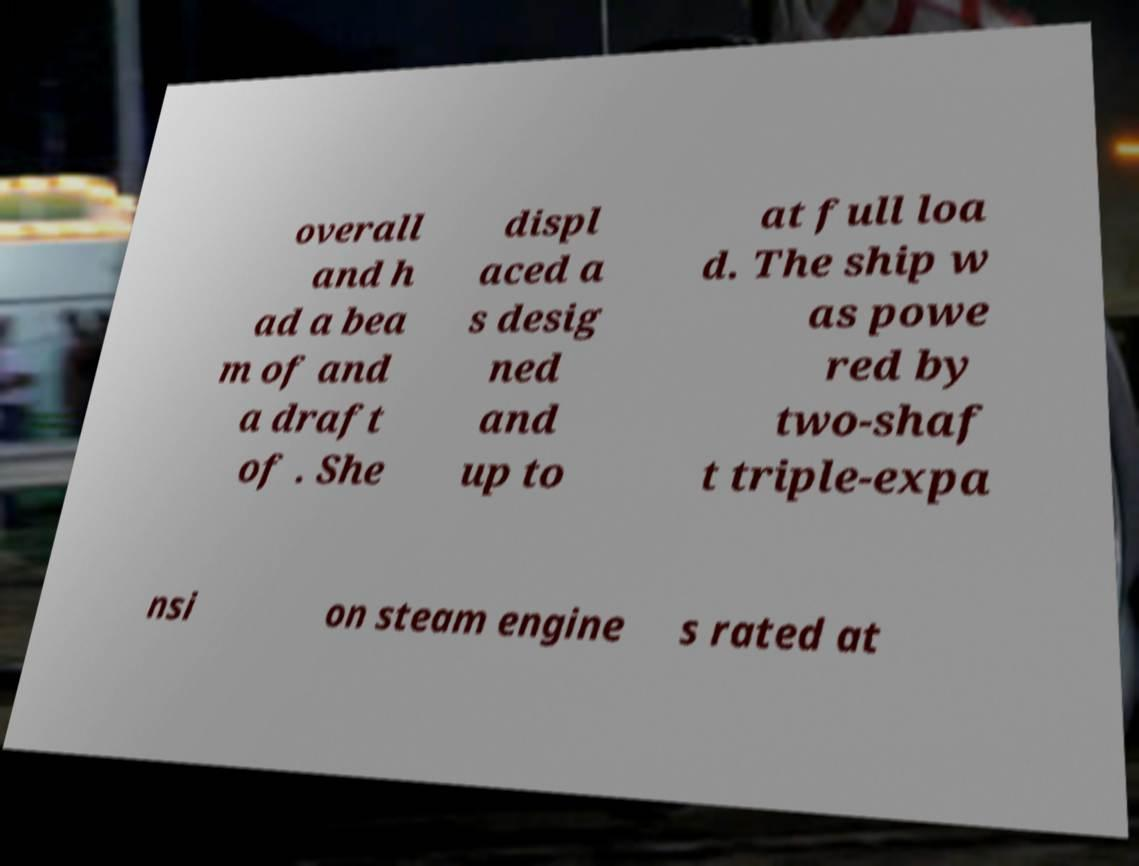I need the written content from this picture converted into text. Can you do that? overall and h ad a bea m of and a draft of . She displ aced a s desig ned and up to at full loa d. The ship w as powe red by two-shaf t triple-expa nsi on steam engine s rated at 